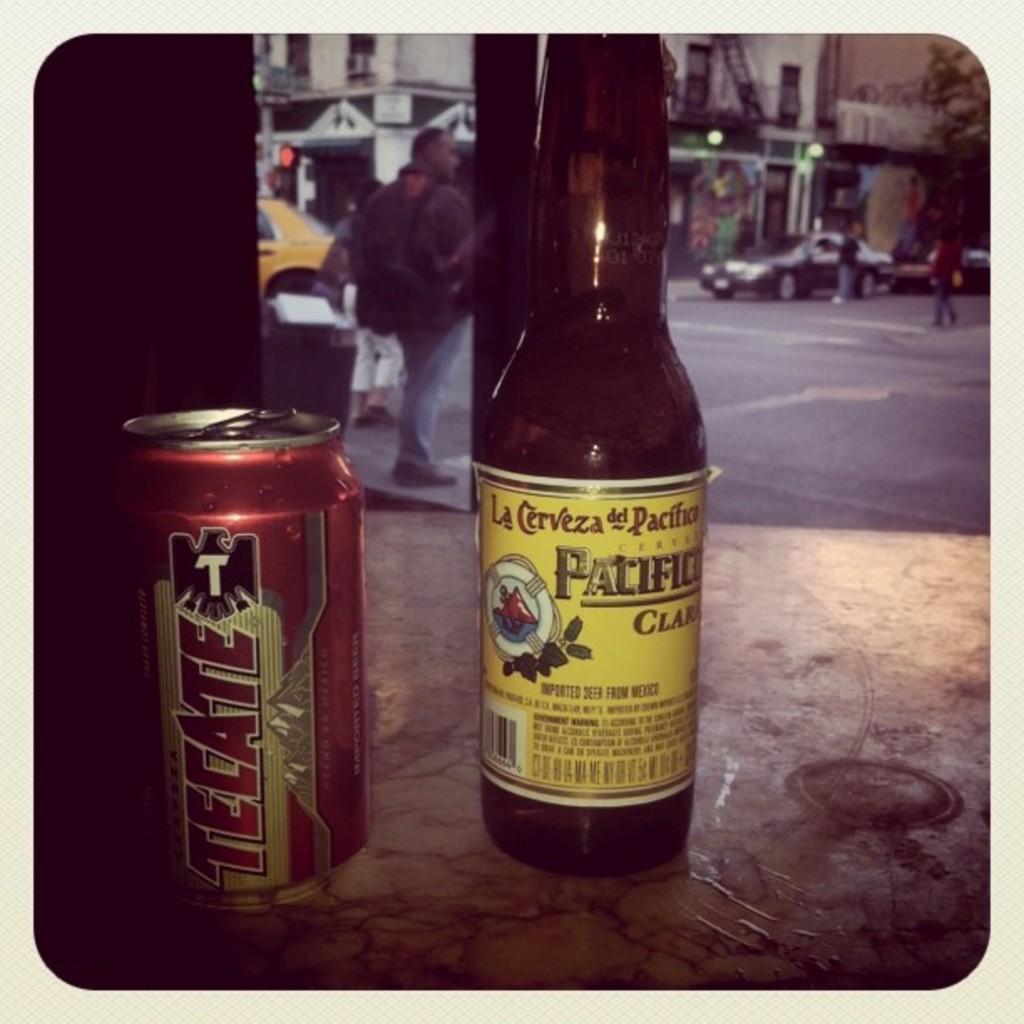What brand is the beer on the left?
Offer a terse response. Tecate. 